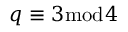Convert formula to latex. <formula><loc_0><loc_0><loc_500><loc_500>q \equiv 3 { \bmod { 4 } }</formula> 